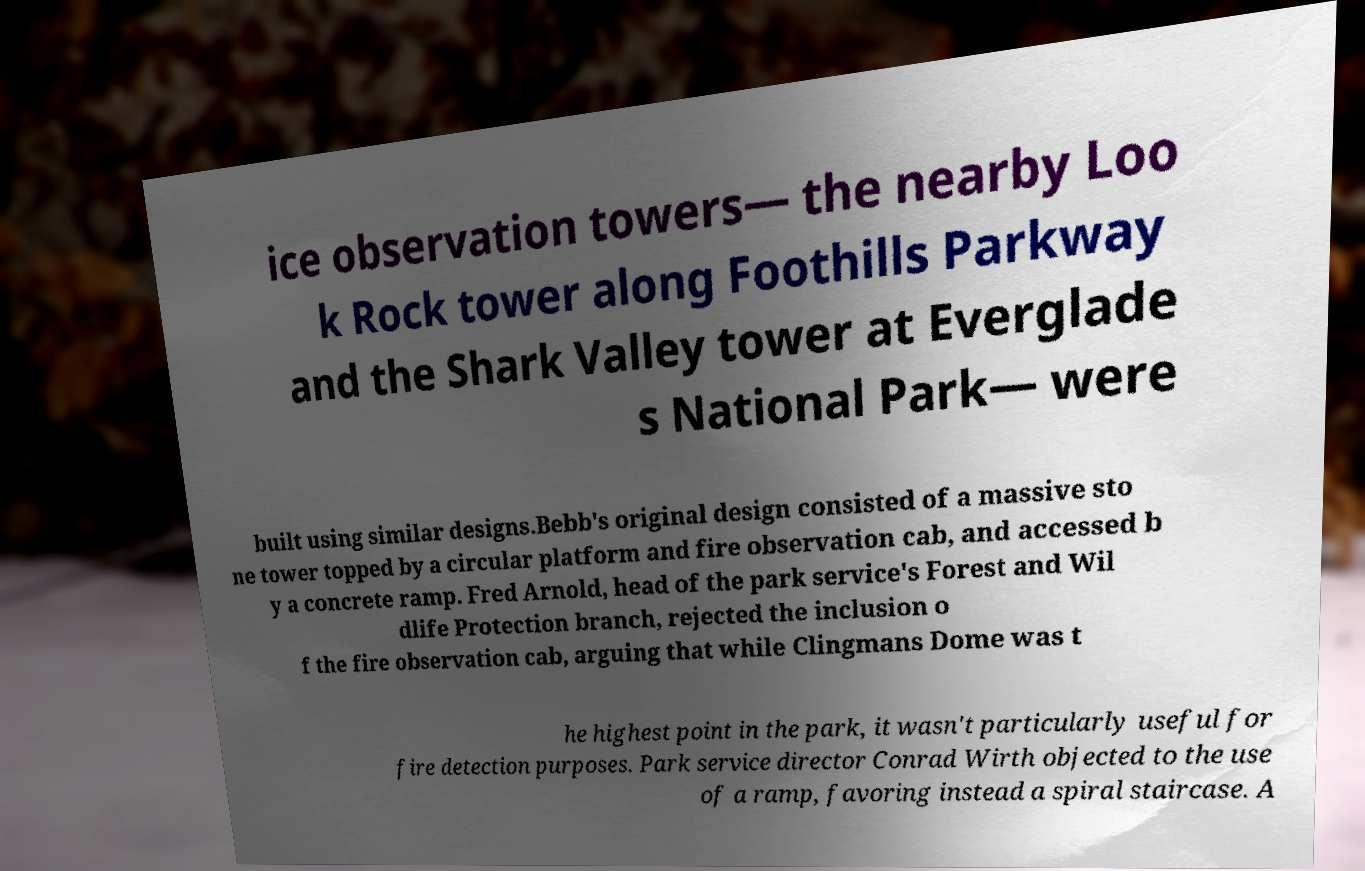Could you extract and type out the text from this image? ice observation towers— the nearby Loo k Rock tower along Foothills Parkway and the Shark Valley tower at Everglade s National Park— were built using similar designs.Bebb's original design consisted of a massive sto ne tower topped by a circular platform and fire observation cab, and accessed b y a concrete ramp. Fred Arnold, head of the park service's Forest and Wil dlife Protection branch, rejected the inclusion o f the fire observation cab, arguing that while Clingmans Dome was t he highest point in the park, it wasn't particularly useful for fire detection purposes. Park service director Conrad Wirth objected to the use of a ramp, favoring instead a spiral staircase. A 